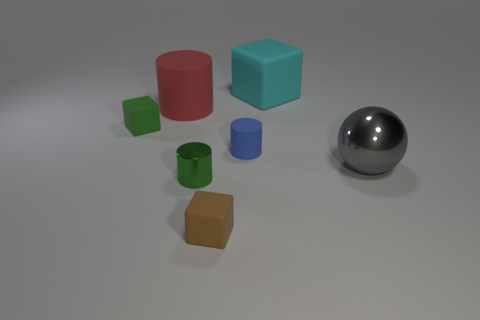Subtract all matte cylinders. How many cylinders are left? 1 Add 2 large cyan metal blocks. How many objects exist? 9 Subtract 1 blocks. How many blocks are left? 2 Subtract all red cylinders. How many cylinders are left? 2 Subtract all balls. How many objects are left? 6 Subtract all blue cubes. Subtract all brown cylinders. How many cubes are left? 3 Add 1 big cubes. How many big cubes exist? 2 Subtract 1 green cylinders. How many objects are left? 6 Subtract all yellow shiny objects. Subtract all blue objects. How many objects are left? 6 Add 7 big gray balls. How many big gray balls are left? 8 